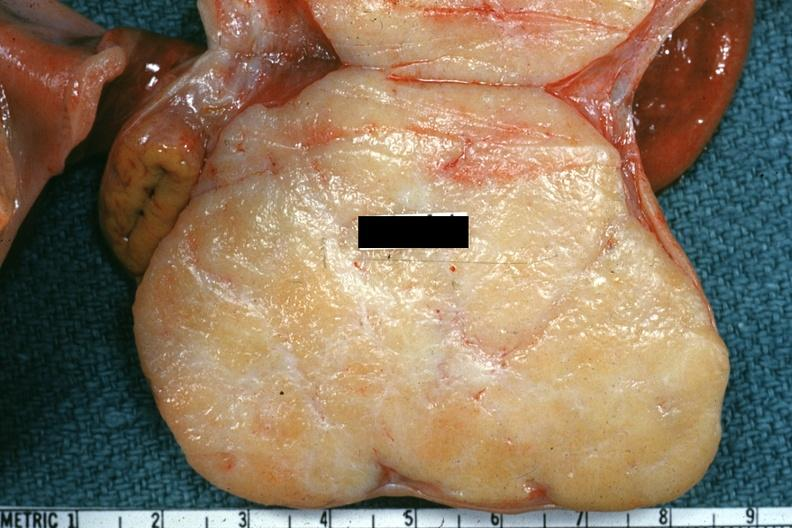what is present?
Answer the question using a single word or phrase. Female reproductive 